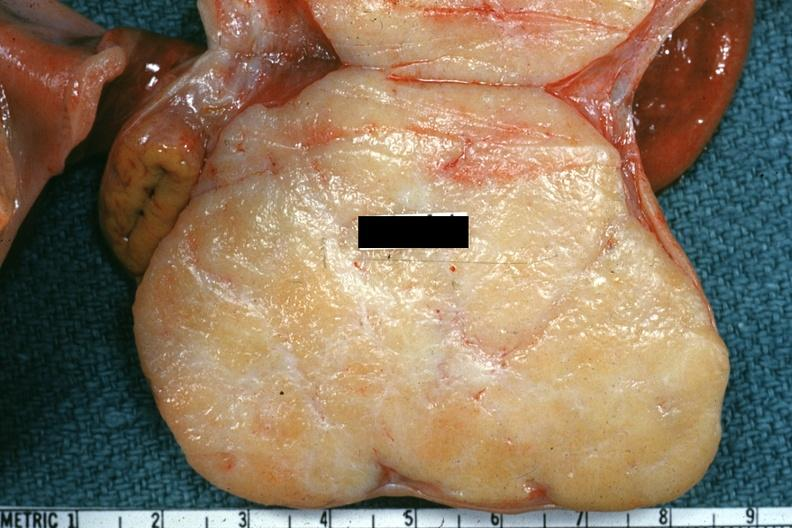what is present?
Answer the question using a single word or phrase. Female reproductive 